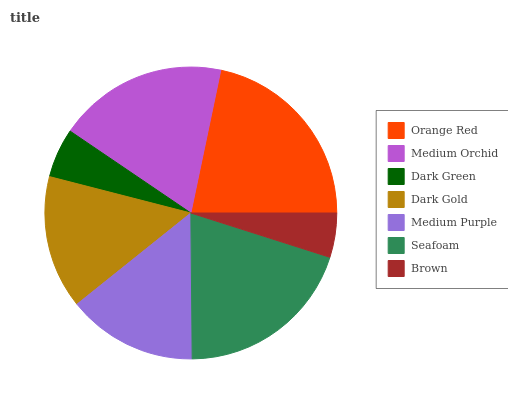Is Brown the minimum?
Answer yes or no. Yes. Is Orange Red the maximum?
Answer yes or no. Yes. Is Medium Orchid the minimum?
Answer yes or no. No. Is Medium Orchid the maximum?
Answer yes or no. No. Is Orange Red greater than Medium Orchid?
Answer yes or no. Yes. Is Medium Orchid less than Orange Red?
Answer yes or no. Yes. Is Medium Orchid greater than Orange Red?
Answer yes or no. No. Is Orange Red less than Medium Orchid?
Answer yes or no. No. Is Dark Gold the high median?
Answer yes or no. Yes. Is Dark Gold the low median?
Answer yes or no. Yes. Is Medium Orchid the high median?
Answer yes or no. No. Is Orange Red the low median?
Answer yes or no. No. 